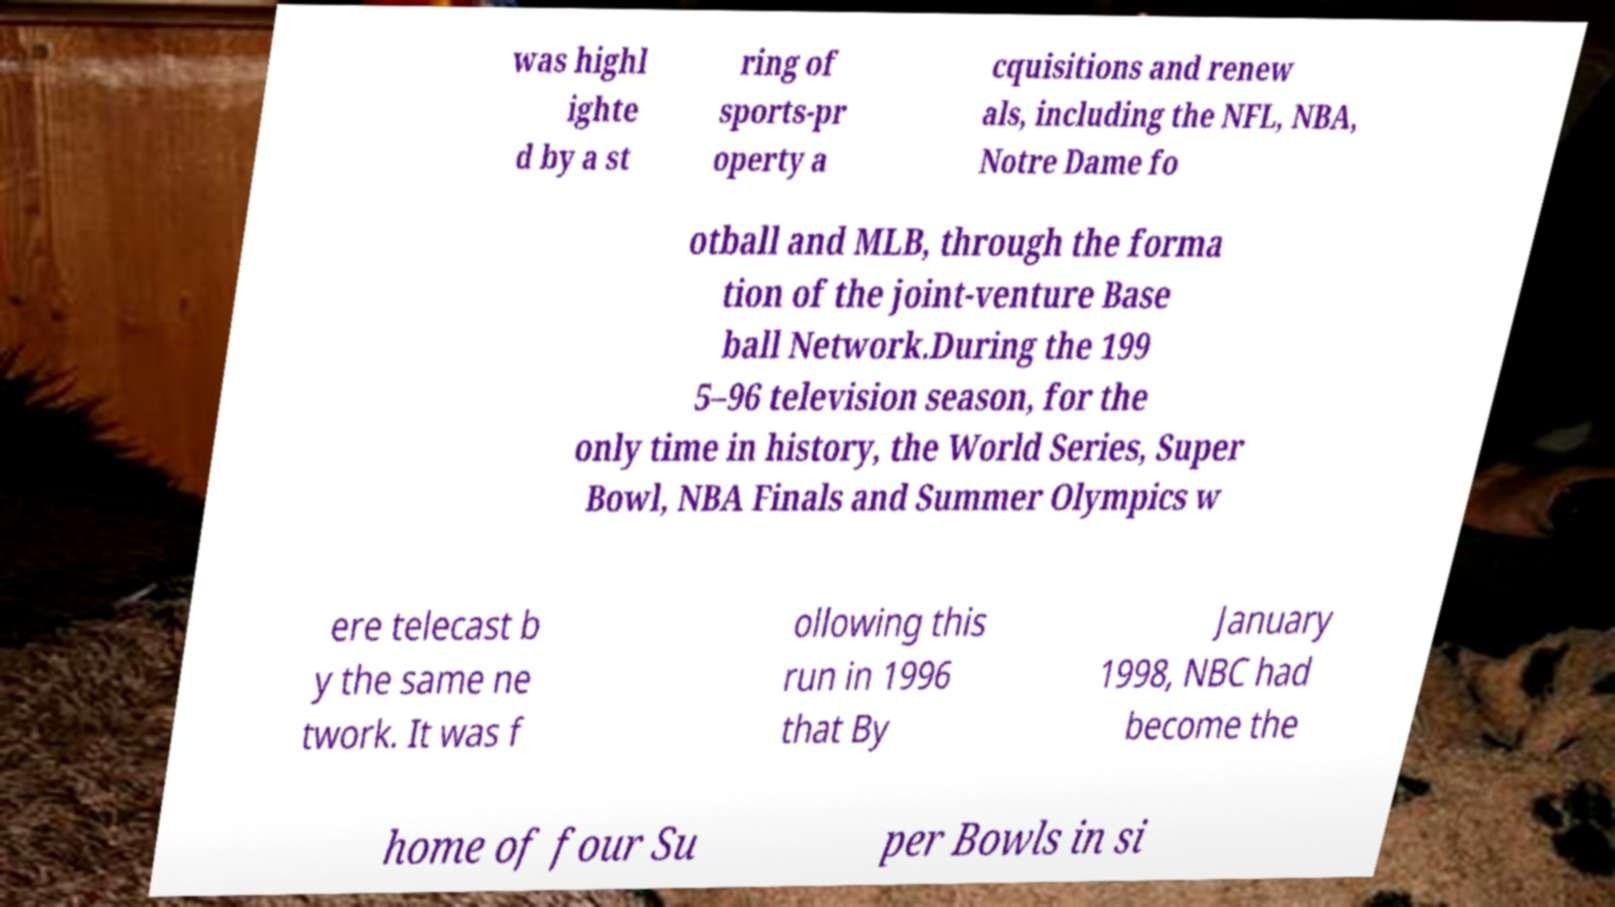Please identify and transcribe the text found in this image. was highl ighte d by a st ring of sports-pr operty a cquisitions and renew als, including the NFL, NBA, Notre Dame fo otball and MLB, through the forma tion of the joint-venture Base ball Network.During the 199 5–96 television season, for the only time in history, the World Series, Super Bowl, NBA Finals and Summer Olympics w ere telecast b y the same ne twork. It was f ollowing this run in 1996 that By January 1998, NBC had become the home of four Su per Bowls in si 